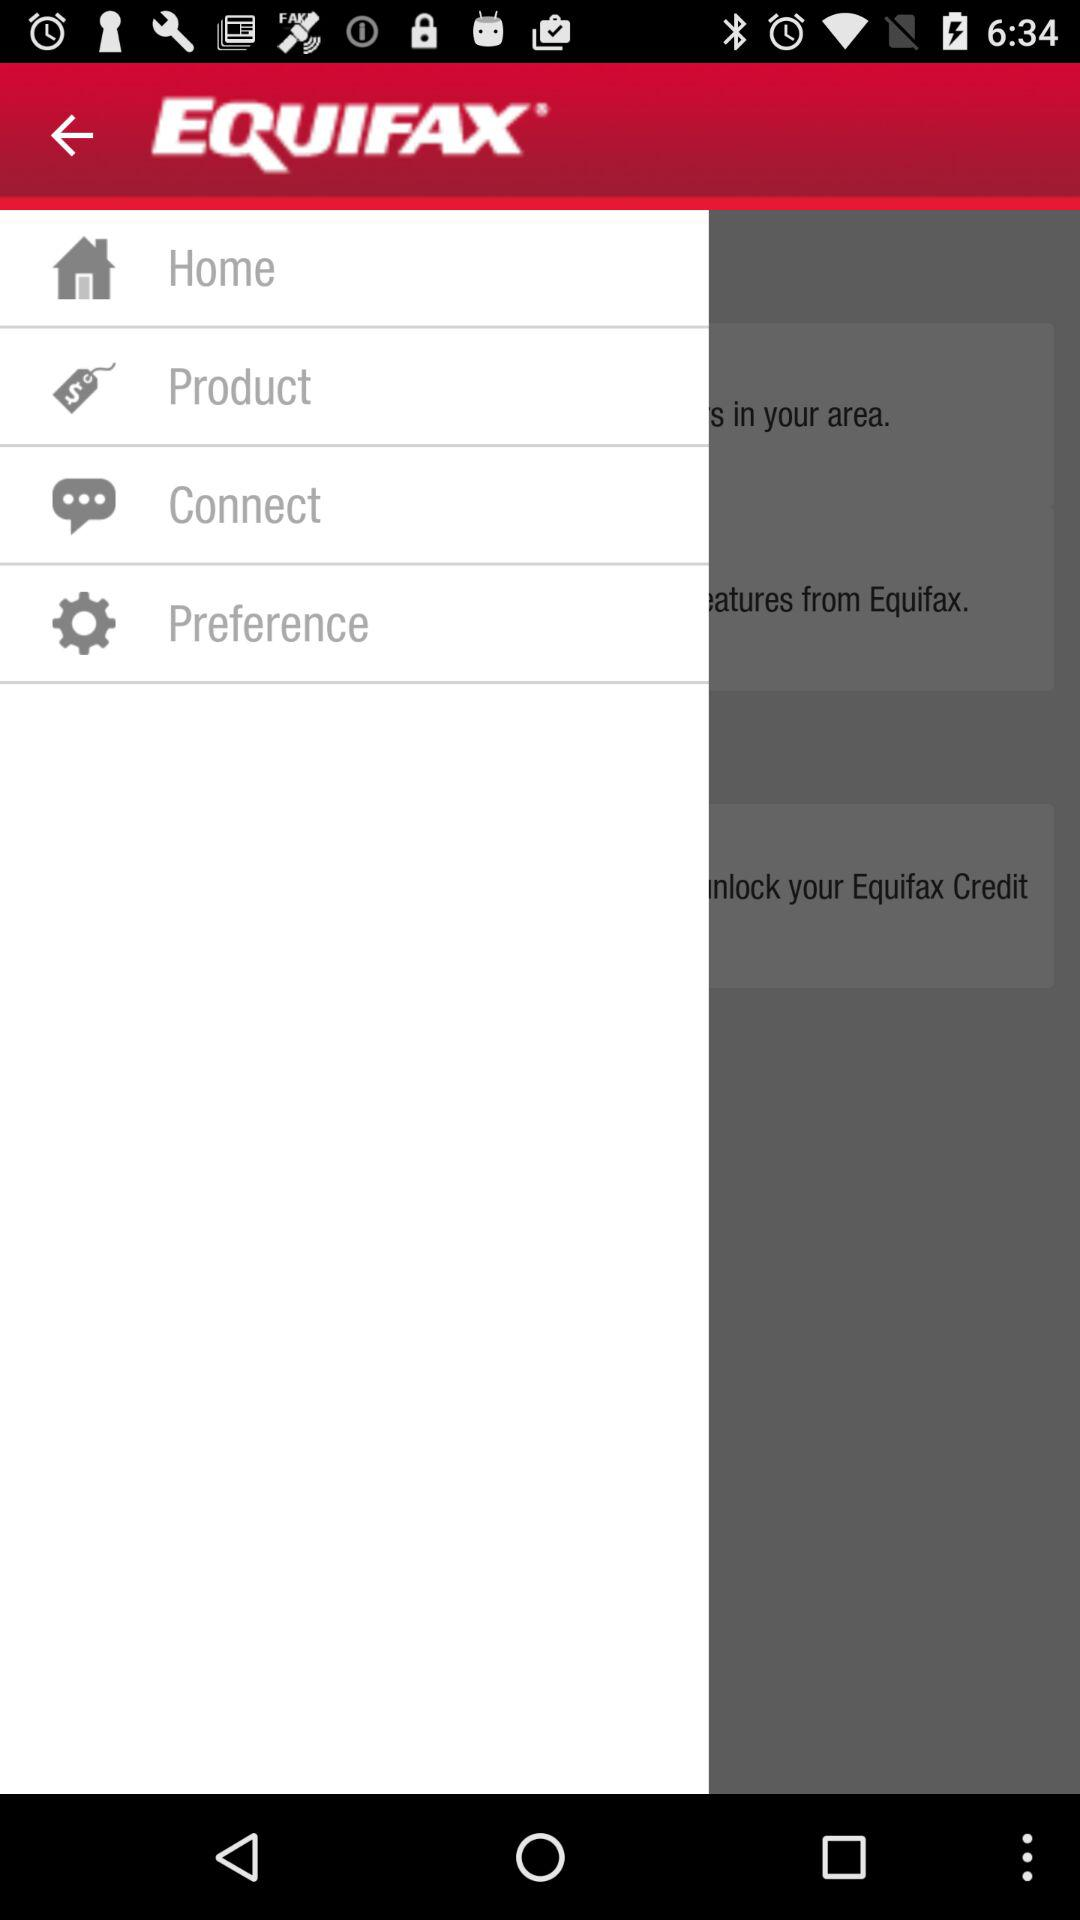What is the name of the application? The name of the application is "EQUIFAX". 